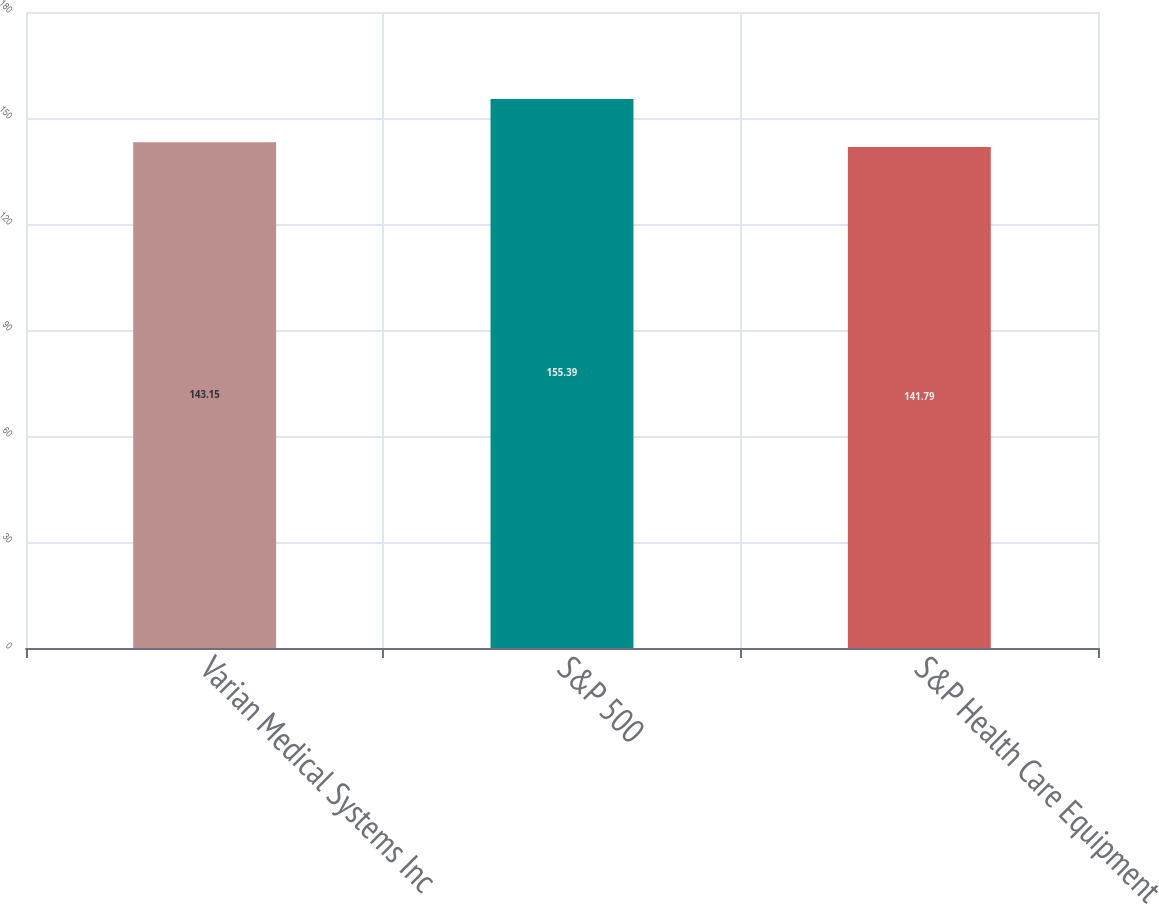<chart> <loc_0><loc_0><loc_500><loc_500><bar_chart><fcel>Varian Medical Systems Inc<fcel>S&P 500<fcel>S&P Health Care Equipment<nl><fcel>143.15<fcel>155.39<fcel>141.79<nl></chart> 